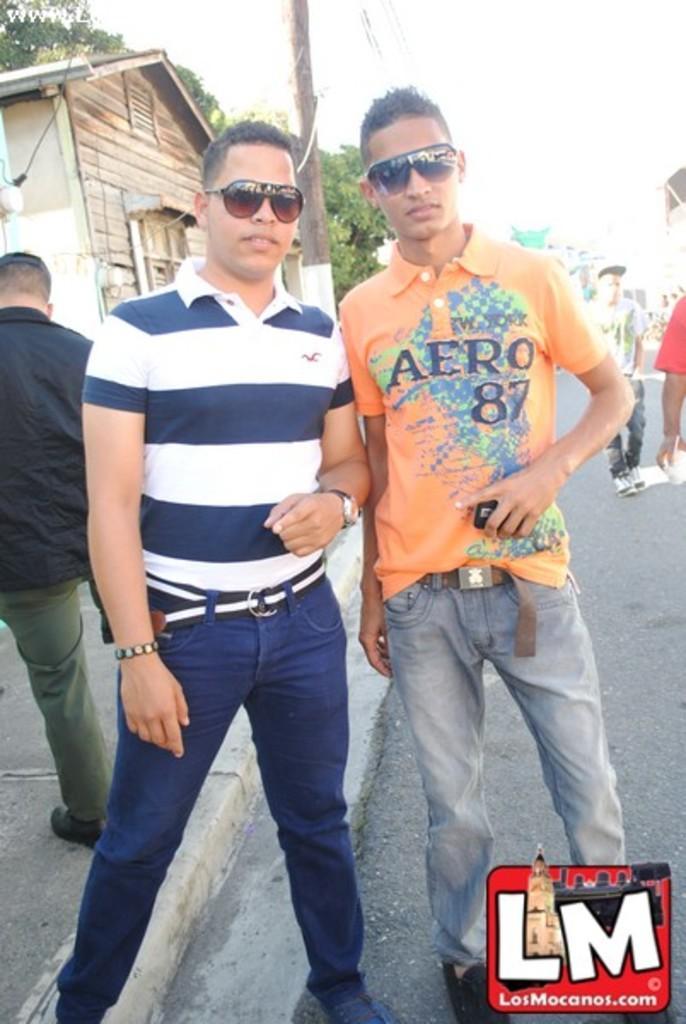Could you give a brief overview of what you see in this image? In this picture we can see two boys wearing a black sunglasses, standing in the front and giving a pose into the camera. Behind there is a wooden small shed. On the bottom side there is a small watermark logo. 